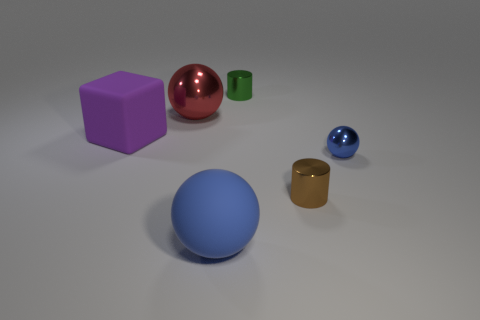How many objects are blue balls to the left of the small green cylinder or large blue matte spheres?
Your answer should be compact. 1. Are there any blue metallic objects of the same size as the brown thing?
Offer a terse response. Yes. What material is the cube that is the same size as the red thing?
Your response must be concise. Rubber. There is a large thing that is to the right of the big matte block and in front of the red ball; what shape is it?
Your answer should be compact. Sphere. There is a large matte object in front of the small brown cylinder; what color is it?
Offer a very short reply. Blue. What size is the metallic object that is behind the large purple object and in front of the green thing?
Make the answer very short. Large. Do the small ball and the big object that is to the right of the red thing have the same material?
Ensure brevity in your answer.  No. How many blue things have the same shape as the big purple object?
Your answer should be very brief. 0. There is a large ball that is the same color as the tiny sphere; what material is it?
Your answer should be very brief. Rubber. How many small green cylinders are there?
Offer a terse response. 1. 